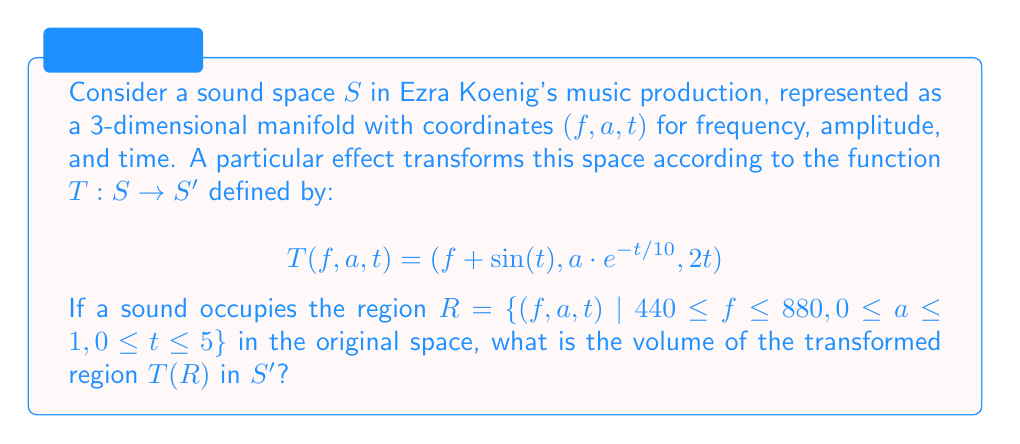Give your solution to this math problem. To solve this problem, we need to follow these steps:

1) First, we need to understand what the transformation does:
   - It shifts the frequency by $\sin(t)$
   - It scales the amplitude by $e^{-t/10}$
   - It doubles the time

2) To find the volume of the transformed region, we need to calculate the Jacobian determinant of the transformation. The Jacobian matrix is:

   $$J = \begin{bmatrix}
   \frac{\partial(f+\sin(t))}{\partial f} & \frac{\partial(f+\sin(t))}{\partial a} & \frac{\partial(f+\sin(t))}{\partial t} \\
   \frac{\partial(a\cdot e^{-t/10})}{\partial f} & \frac{\partial(a\cdot e^{-t/10})}{\partial a} & \frac{\partial(a\cdot e^{-t/10})}{\partial t} \\
   \frac{\partial(2t)}{\partial f} & \frac{\partial(2t)}{\partial a} & \frac{\partial(2t)}{\partial t}
   \end{bmatrix}$$

   $$J = \begin{bmatrix}
   1 & 0 & \cos(t) \\
   0 & e^{-t/10} & -\frac{1}{10}a\cdot e^{-t/10} \\
   0 & 0 & 2
   \end{bmatrix}$$

3) The Jacobian determinant is:

   $$|J| = 1 \cdot e^{-t/10} \cdot 2 = 2e^{-t/10}$$

4) The volume of the transformed region is given by the integral:

   $$V = \int_{T(R)} dV' = \int_R |J| dV$$

   $$V = \int_0^5 \int_0^1 \int_{440}^{880} 2e^{-t/10} df da dt$$

5) Evaluating the integral:

   $$V = 2 \int_0^5 \int_0^1 \int_{440}^{880} e^{-t/10} df da dt$$
   $$= 2 \cdot 440 \cdot 1 \cdot \int_0^5 e^{-t/10} dt$$
   $$= 880 \cdot [-10e^{-t/10}]_0^5$$
   $$= 880 \cdot (10 - 10e^{-1/2})$$
   $$= 8800 \cdot (1 - e^{-1/2})$$

6) Evaluating this expression gives us the final answer.
Answer: The volume of the transformed region $T(R)$ is approximately 2763.85 cubic units in the $(f, a, t)$ space. 